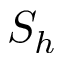Convert formula to latex. <formula><loc_0><loc_0><loc_500><loc_500>S _ { h }</formula> 